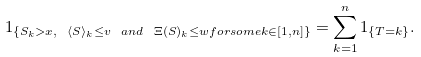Convert formula to latex. <formula><loc_0><loc_0><loc_500><loc_500>1 _ { \{ S _ { k } > x , \ \langle S \rangle _ { k } \leq v \ a n d \ \Xi ( S ) _ { k } \leq w f o r s o m e k \in [ 1 , n ] \} } = \sum _ { k = 1 } ^ { n } 1 _ { \{ T = k \} } .</formula> 